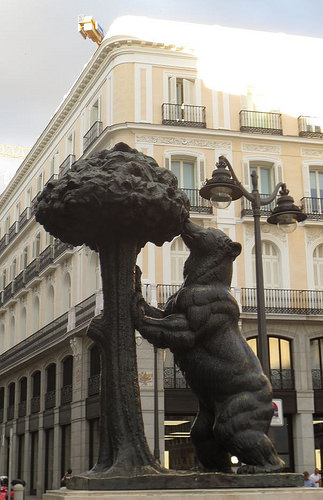<image>
Can you confirm if the bear is under the streetlight? Yes. The bear is positioned underneath the streetlight, with the streetlight above it in the vertical space. Where is the bear in relation to the main street? Is it in the main street? Yes. The bear is contained within or inside the main street, showing a containment relationship. 